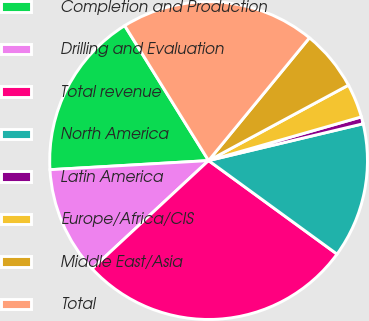Convert chart. <chart><loc_0><loc_0><loc_500><loc_500><pie_chart><fcel>Completion and Production<fcel>Drilling and Evaluation<fcel>Total revenue<fcel>North America<fcel>Latin America<fcel>Europe/Africa/CIS<fcel>Middle East/Asia<fcel>Total<nl><fcel>17.06%<fcel>11.0%<fcel>28.07%<fcel>13.74%<fcel>0.71%<fcel>3.44%<fcel>6.18%<fcel>19.8%<nl></chart> 